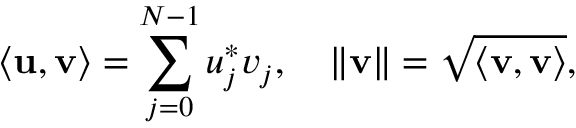Convert formula to latex. <formula><loc_0><loc_0><loc_500><loc_500>\langle { \mathbf u } , { \mathbf v } \rangle = \sum _ { j = 0 } ^ { N - 1 } { u } _ { j } ^ { * } v _ { j } , \quad \| { \mathbf v } \| = \sqrt { \langle { \mathbf v } , { \mathbf v } \rangle } ,</formula> 